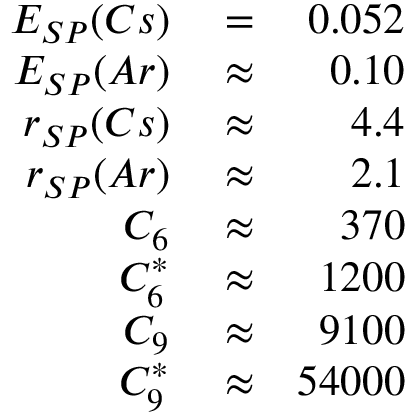<formula> <loc_0><loc_0><loc_500><loc_500>\begin{array} { r l r } { E _ { S P } ( C s ) } & = } & { 0 . 0 5 2 } \\ { E _ { S P } ( A r ) } & \approx } & { 0 . 1 0 } \\ { r _ { S P } ( C s ) } & \approx } & { 4 . 4 } \\ { r _ { S P } ( A r ) } & \approx } & { 2 . 1 } \\ { C _ { 6 } } & \approx } & { 3 7 0 } \\ { C _ { 6 } ^ { * } } & \approx } & { 1 2 0 0 } \\ { C _ { 9 } } & \approx } & { 9 1 0 0 } \\ { C _ { 9 } ^ { * } } & \approx } & { 5 4 0 0 0 } \end{array}</formula> 